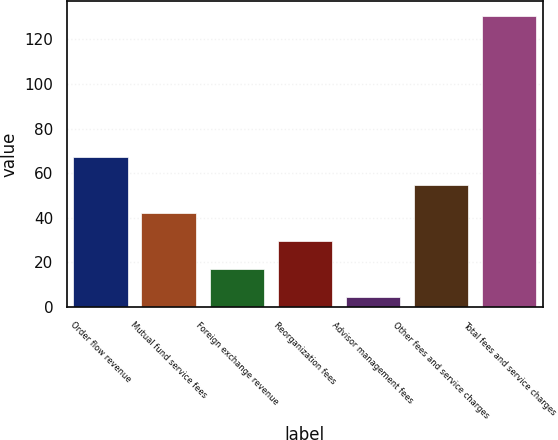<chart> <loc_0><loc_0><loc_500><loc_500><bar_chart><fcel>Order flow revenue<fcel>Mutual fund service fees<fcel>Foreign exchange revenue<fcel>Reorganization fees<fcel>Advisor management fees<fcel>Other fees and service charges<fcel>Total fees and service charges<nl><fcel>67.4<fcel>42.2<fcel>17<fcel>29.6<fcel>4.4<fcel>54.8<fcel>130.4<nl></chart> 